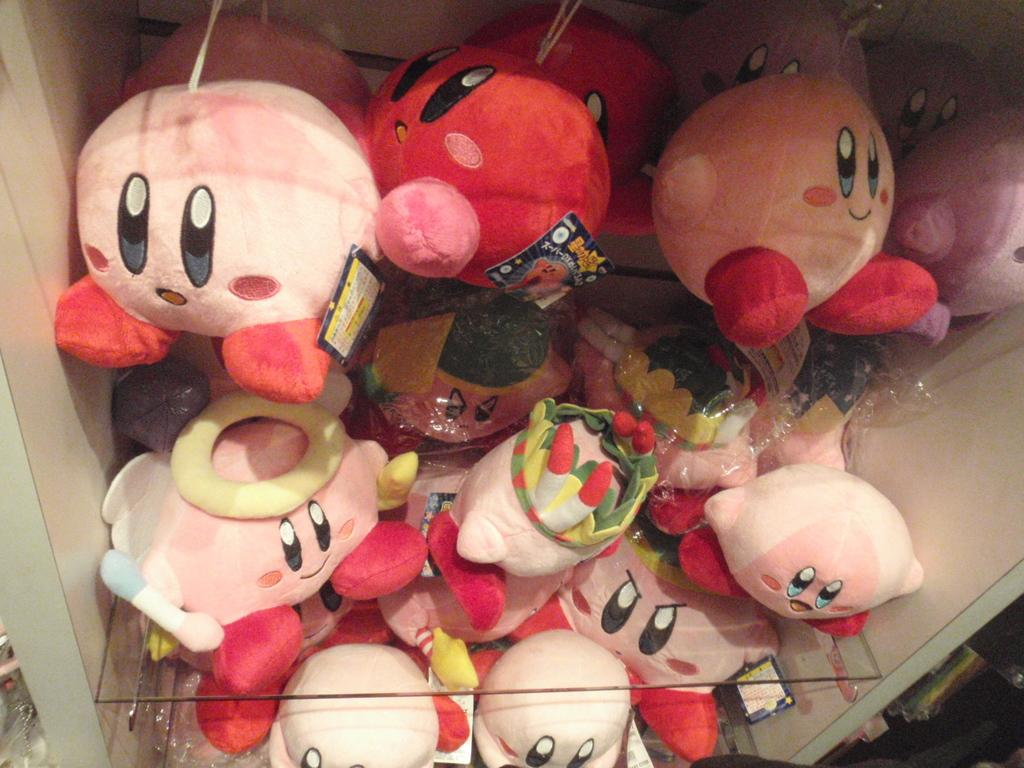What objects can be seen in the image? There are toys in the image. Where are the toys located? The toys are on a rack. What type of ship can be seen sailing in the image? There is no ship present in the image; it only features toys on a rack. What appliance is being used to clean the toys in the image? There is no appliance visible in the image, as it only shows toys on a rack. 